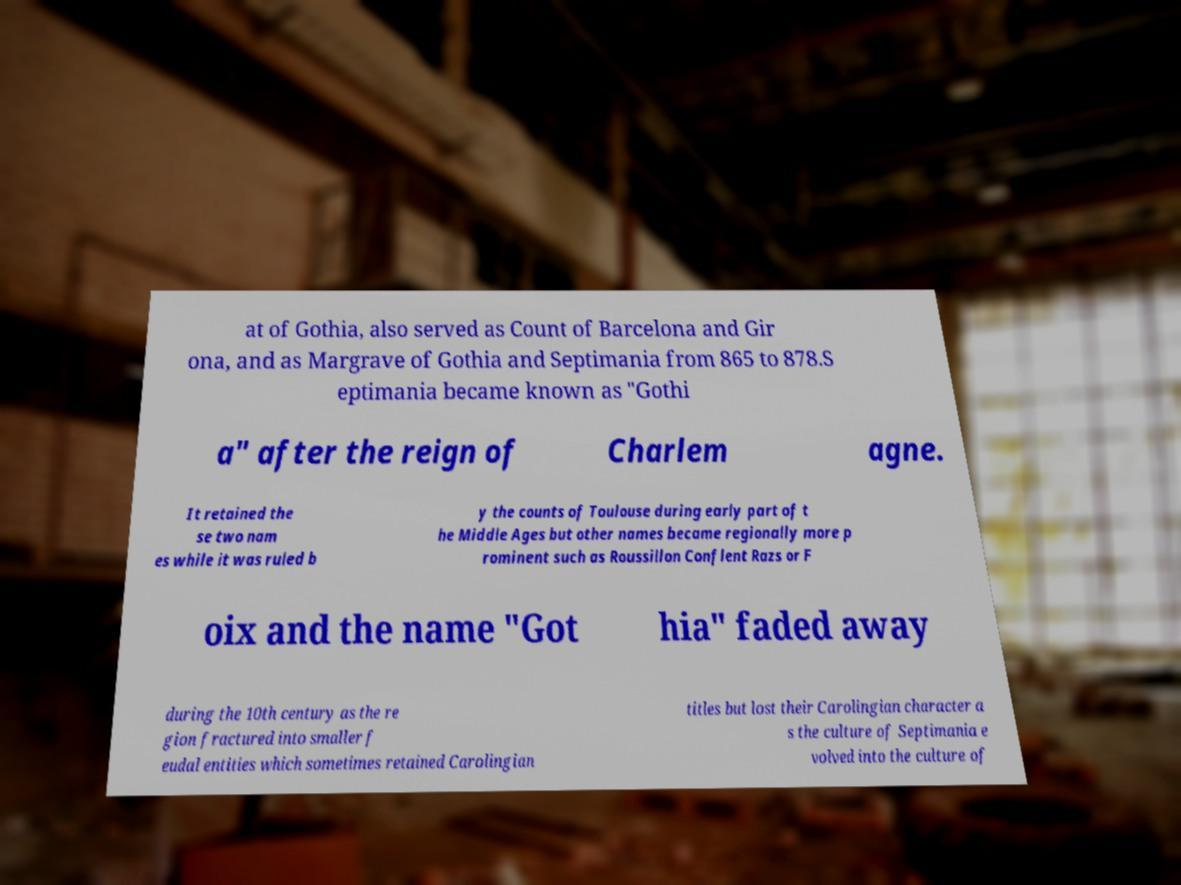Could you extract and type out the text from this image? at of Gothia, also served as Count of Barcelona and Gir ona, and as Margrave of Gothia and Septimania from 865 to 878.S eptimania became known as "Gothi a" after the reign of Charlem agne. It retained the se two nam es while it was ruled b y the counts of Toulouse during early part of t he Middle Ages but other names became regionally more p rominent such as Roussillon Conflent Razs or F oix and the name "Got hia" faded away during the 10th century as the re gion fractured into smaller f eudal entities which sometimes retained Carolingian titles but lost their Carolingian character a s the culture of Septimania e volved into the culture of 